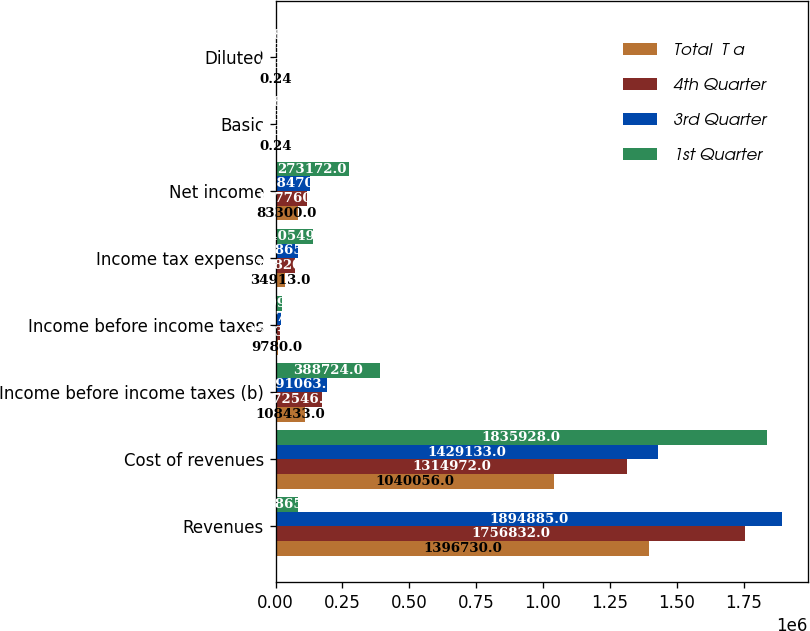Convert chart. <chart><loc_0><loc_0><loc_500><loc_500><stacked_bar_chart><ecel><fcel>Revenues<fcel>Cost of revenues<fcel>Income before income taxes (b)<fcel>Income before income taxes<fcel>Income tax expense<fcel>Net income<fcel>Basic<fcel>Diluted<nl><fcel>Total  T a<fcel>1.39673e+06<fcel>1.04006e+06<fcel>108433<fcel>9780<fcel>34913<fcel>83300<fcel>0.24<fcel>0.24<nl><fcel>4th Quarter<fcel>1.75683e+06<fcel>1.31497e+06<fcel>172546<fcel>17034<fcel>71820<fcel>117760<fcel>0.34<fcel>0.34<nl><fcel>3rd Quarter<fcel>1.89488e+06<fcel>1.42913e+06<fcel>191063<fcel>21272<fcel>83865<fcel>128470<fcel>0.37<fcel>0.37<nl><fcel>1st Quarter<fcel>83865<fcel>1.83593e+06<fcel>388724<fcel>24997<fcel>140549<fcel>273172<fcel>0.83<fcel>0.83<nl></chart> 